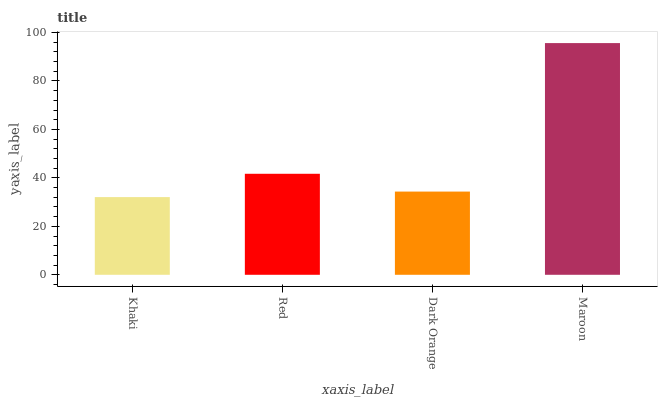Is Khaki the minimum?
Answer yes or no. Yes. Is Maroon the maximum?
Answer yes or no. Yes. Is Red the minimum?
Answer yes or no. No. Is Red the maximum?
Answer yes or no. No. Is Red greater than Khaki?
Answer yes or no. Yes. Is Khaki less than Red?
Answer yes or no. Yes. Is Khaki greater than Red?
Answer yes or no. No. Is Red less than Khaki?
Answer yes or no. No. Is Red the high median?
Answer yes or no. Yes. Is Dark Orange the low median?
Answer yes or no. Yes. Is Khaki the high median?
Answer yes or no. No. Is Maroon the low median?
Answer yes or no. No. 